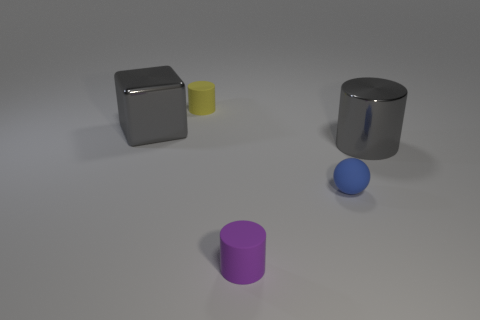Add 5 cylinders. How many objects exist? 10 Subtract all cylinders. How many objects are left? 2 Add 3 blue matte things. How many blue matte things exist? 4 Subtract 0 gray balls. How many objects are left? 5 Subtract all yellow matte cylinders. Subtract all blue things. How many objects are left? 3 Add 4 gray metal cylinders. How many gray metal cylinders are left? 5 